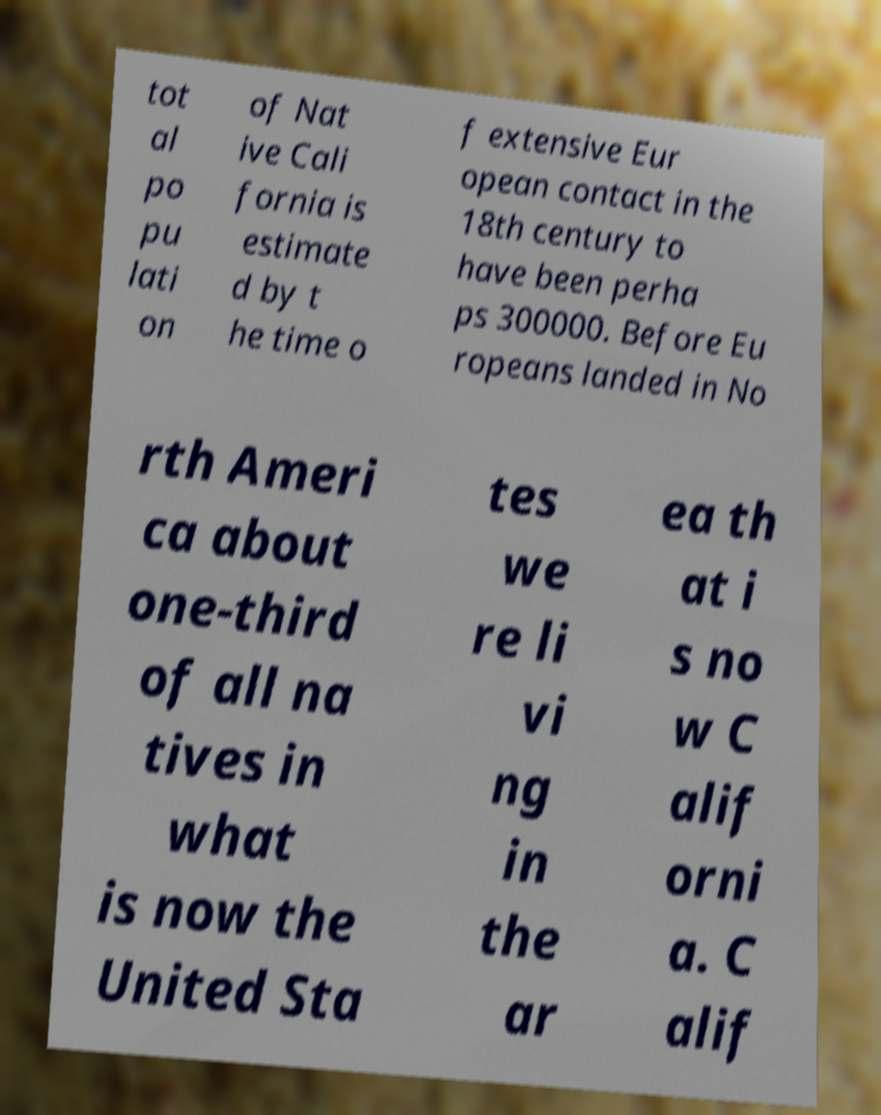I need the written content from this picture converted into text. Can you do that? tot al po pu lati on of Nat ive Cali fornia is estimate d by t he time o f extensive Eur opean contact in the 18th century to have been perha ps 300000. Before Eu ropeans landed in No rth Ameri ca about one-third of all na tives in what is now the United Sta tes we re li vi ng in the ar ea th at i s no w C alif orni a. C alif 